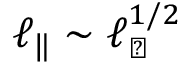<formula> <loc_0><loc_0><loc_500><loc_500>\ell _ { \| } \sim \ell _ { \perp } ^ { 1 / 2 }</formula> 